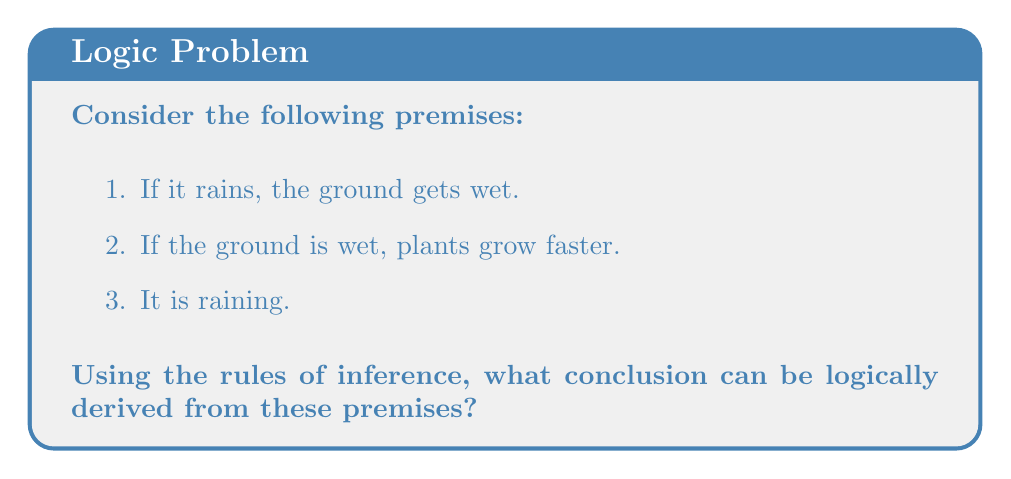Show me your answer to this math problem. Let's approach this step-by-step using the rules of inference:

1. First, let's define our propositions:
   $p$: It rains
   $q$: The ground gets wet
   $r$: Plants grow faster

2. Now, we can rewrite our premises using these propositions:
   Premise 1: $p \rightarrow q$ (If it rains, then the ground gets wet)
   Premise 2: $q \rightarrow r$ (If the ground is wet, then plants grow faster)
   Premise 3: $p$ (It is raining)

3. We can use the Modus Ponens rule of inference twice:
   a. Modus Ponens states that if we have $p \rightarrow q$ and $p$, we can conclude $q$.
   b. From Premise 1 $(p \rightarrow q)$ and Premise 3 $(p)$, we can conclude $q$ (The ground gets wet).
   c. Now we have $q$, and from Premise 2 $(q \rightarrow r)$, we can apply Modus Ponens again.
   d. This allows us to conclude $r$ (Plants grow faster).

4. Therefore, using the rules of inference, we can logically conclude that plants grow faster.

This process is also known as the Law of Syllogism or Chain Rule, which states that if $p \rightarrow q$ and $q \rightarrow r$, then $p \rightarrow r$.
Answer: Plants grow faster. 